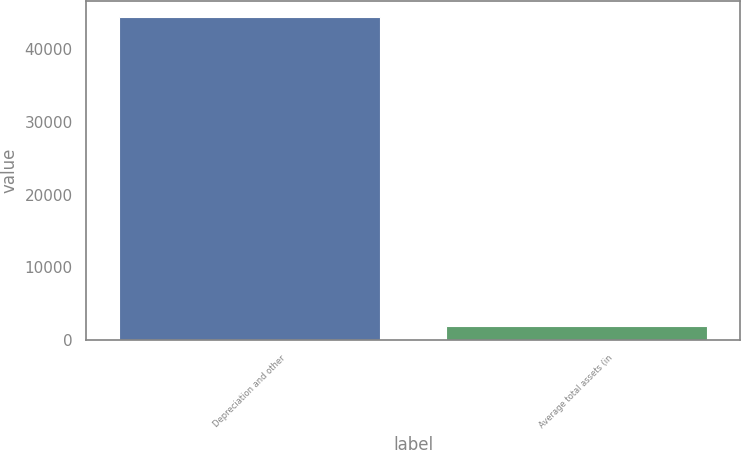<chart> <loc_0><loc_0><loc_500><loc_500><bar_chart><fcel>Depreciation and other<fcel>Average total assets (in<nl><fcel>44349<fcel>1958<nl></chart> 